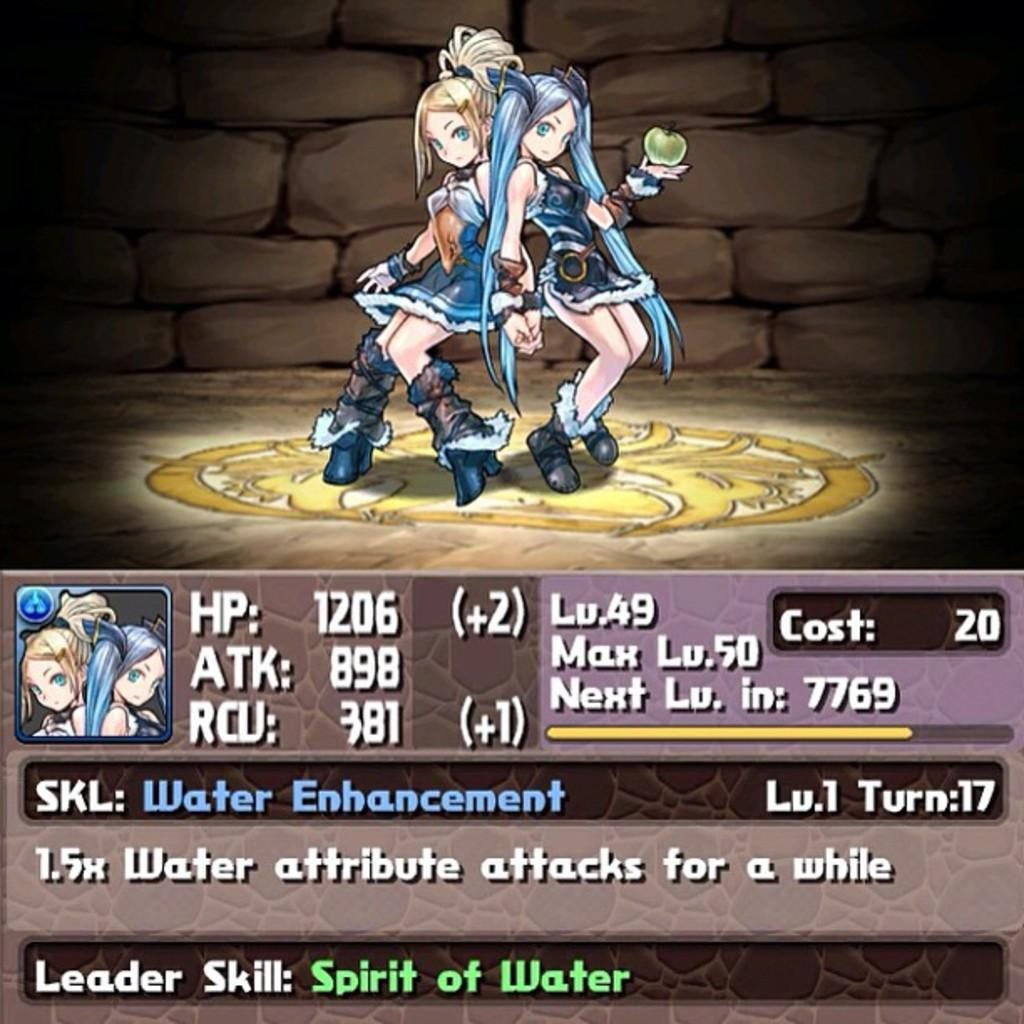How many people are in the image? There are two depicted persons in the image. What is one person holding? One person is holding an apple. What is behind the person holding the apple? There is a wall behind the person. What can be found on the image besides the depicted persons and the wall? There is text on the image. How does the depicted person's wealth compare to the other person in the image? There is no information about the depicted persons' wealth in the image, so it cannot be compared. --- Facts: 1. There is a car in the image. 2. The car is parked on the street. 3. There are trees on the side of the street. 4. The sky is visible in the image. Absurd Topics: parade, elephant, dance Conversation: What is the main subject of the image? The main subject of the image is a car. Where is the car located in the image? The car is parked on the street. What can be seen on the side of the street? There are trees on the side of the street. What is visible in the background of the image? The sky is visible in the image. Reasoning: Let's think step by step in order to produce the conversation. We start by identifying the main subject in the image, which is the car. Then, we describe the location of the car, which is parked on the street. Next, we mention the presence of trees on the side of the street. Finally, we acknowledge the presence of the sky in the background of the image. Absurd Question/Answer: Can you tell me how many elephants are participating in the parade in the image? There is no parade or elephants present in the image. What type of dance is being performed by the depicted person in the image? There is no depicted person performing a dance in the image. 